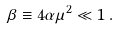Convert formula to latex. <formula><loc_0><loc_0><loc_500><loc_500>\beta \equiv 4 \alpha \mu ^ { 2 } \ll 1 \, .</formula> 